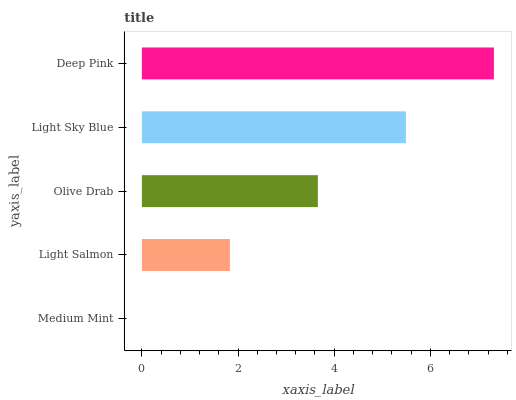Is Medium Mint the minimum?
Answer yes or no. Yes. Is Deep Pink the maximum?
Answer yes or no. Yes. Is Light Salmon the minimum?
Answer yes or no. No. Is Light Salmon the maximum?
Answer yes or no. No. Is Light Salmon greater than Medium Mint?
Answer yes or no. Yes. Is Medium Mint less than Light Salmon?
Answer yes or no. Yes. Is Medium Mint greater than Light Salmon?
Answer yes or no. No. Is Light Salmon less than Medium Mint?
Answer yes or no. No. Is Olive Drab the high median?
Answer yes or no. Yes. Is Olive Drab the low median?
Answer yes or no. Yes. Is Deep Pink the high median?
Answer yes or no. No. Is Medium Mint the low median?
Answer yes or no. No. 